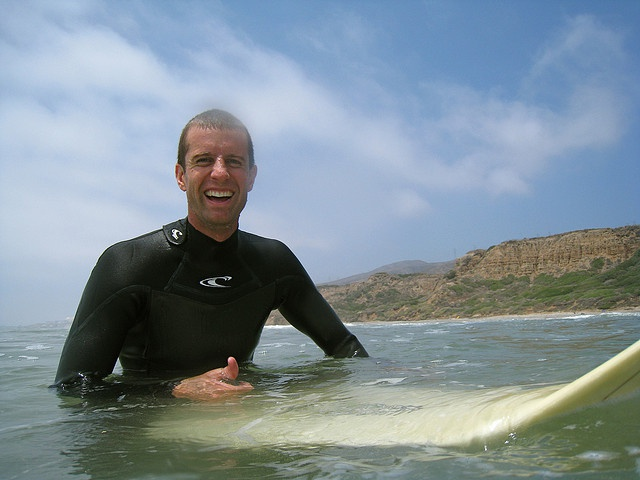Describe the objects in this image and their specific colors. I can see people in darkgray, black, gray, and maroon tones and surfboard in darkgray, beige, and olive tones in this image. 